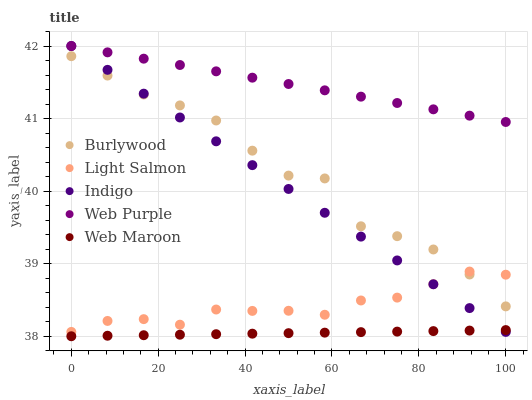Does Web Maroon have the minimum area under the curve?
Answer yes or no. Yes. Does Web Purple have the maximum area under the curve?
Answer yes or no. Yes. Does Light Salmon have the minimum area under the curve?
Answer yes or no. No. Does Light Salmon have the maximum area under the curve?
Answer yes or no. No. Is Indigo the smoothest?
Answer yes or no. Yes. Is Burlywood the roughest?
Answer yes or no. Yes. Is Web Maroon the smoothest?
Answer yes or no. No. Is Web Maroon the roughest?
Answer yes or no. No. Does Web Maroon have the lowest value?
Answer yes or no. Yes. Does Light Salmon have the lowest value?
Answer yes or no. No. Does Web Purple have the highest value?
Answer yes or no. Yes. Does Light Salmon have the highest value?
Answer yes or no. No. Is Burlywood less than Web Purple?
Answer yes or no. Yes. Is Web Purple greater than Light Salmon?
Answer yes or no. Yes. Does Indigo intersect Web Purple?
Answer yes or no. Yes. Is Indigo less than Web Purple?
Answer yes or no. No. Is Indigo greater than Web Purple?
Answer yes or no. No. Does Burlywood intersect Web Purple?
Answer yes or no. No. 